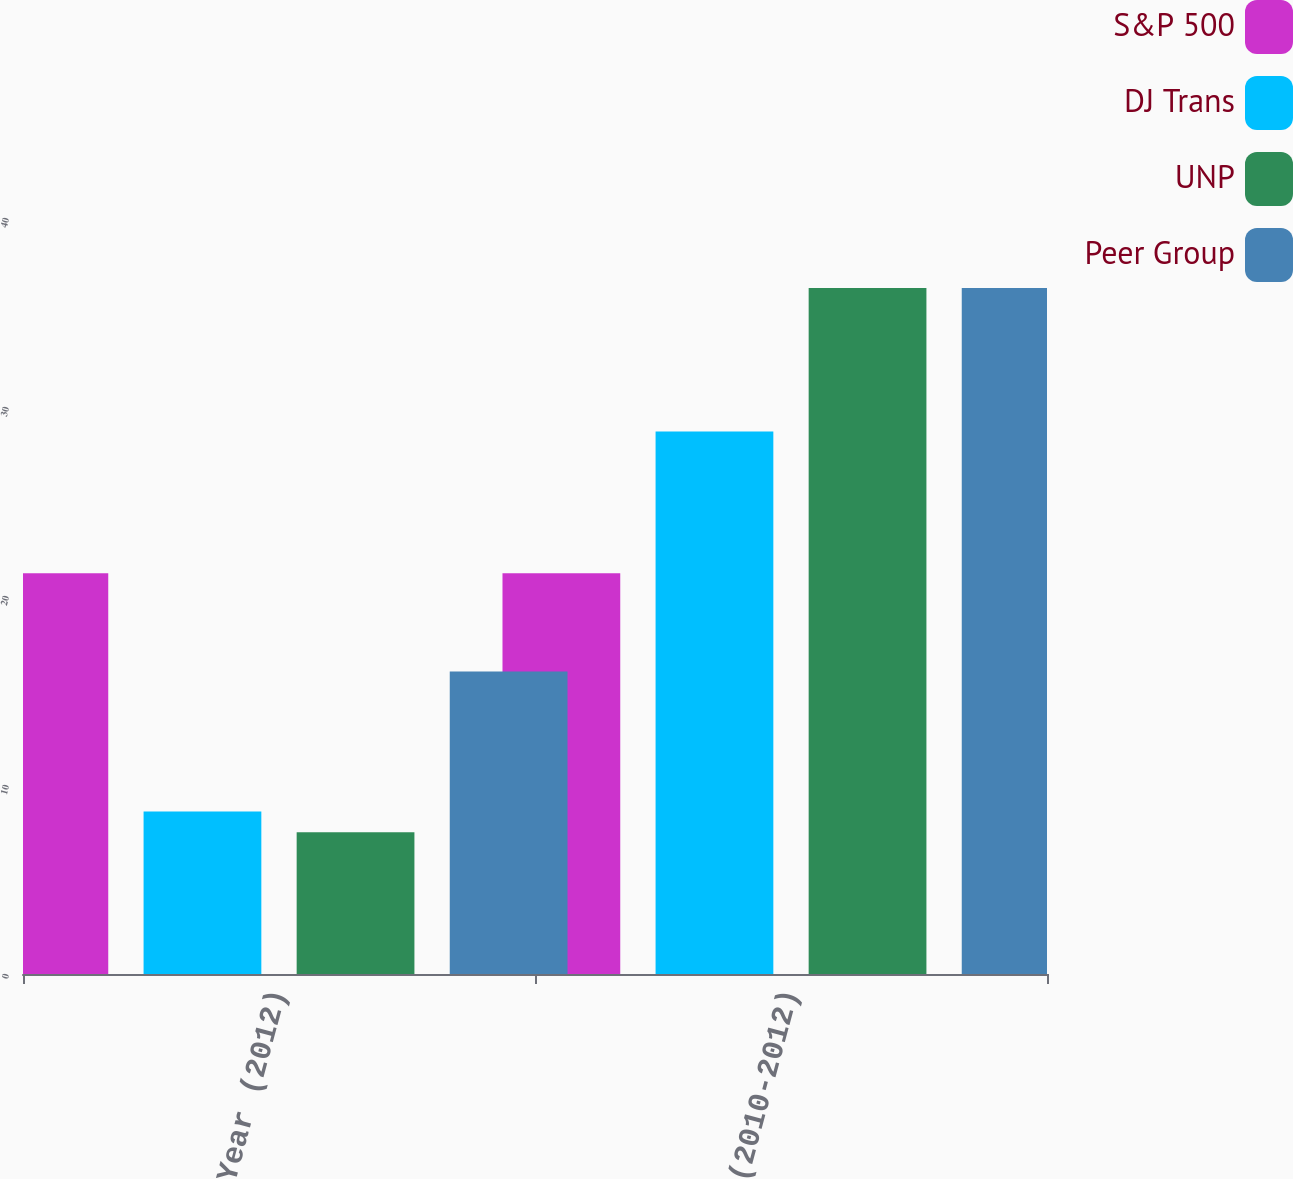<chart> <loc_0><loc_0><loc_500><loc_500><stacked_bar_chart><ecel><fcel>1 Year (2012)<fcel>3 Year (2010-2012)<nl><fcel>S&P 500<fcel>21.2<fcel>21.2<nl><fcel>DJ Trans<fcel>8.6<fcel>28.7<nl><fcel>UNP<fcel>7.5<fcel>36.3<nl><fcel>Peer Group<fcel>16<fcel>36.3<nl></chart> 